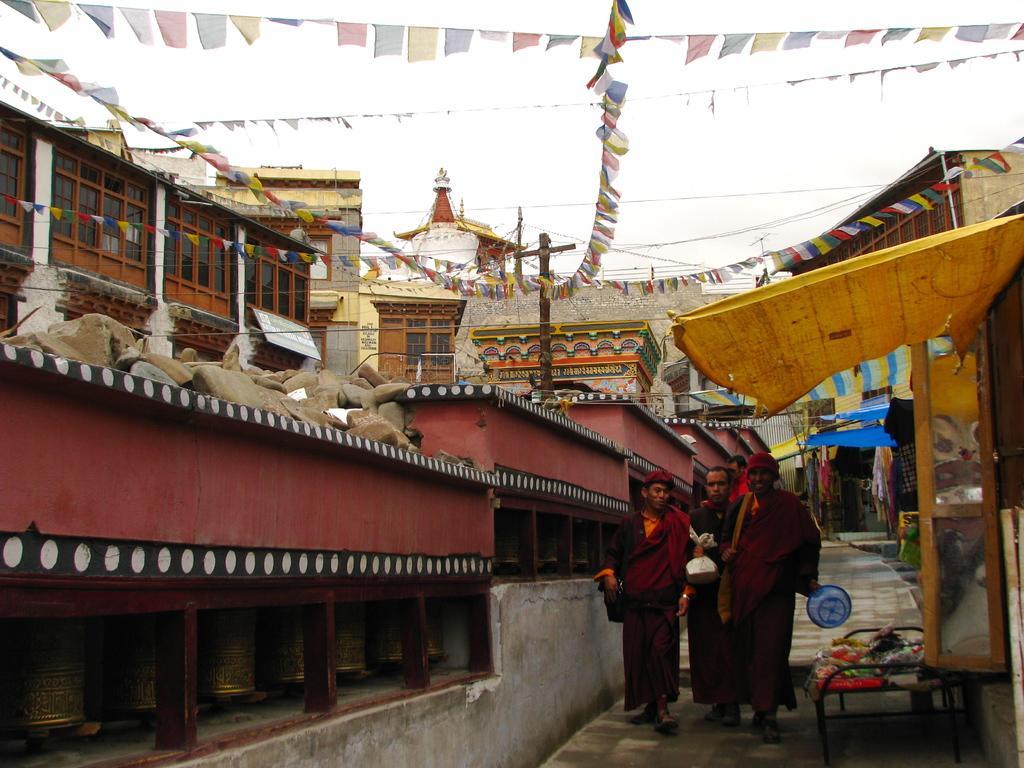Please provide a concise description of this image. In this picture I see the path in the center and I see few people who are on it and on the left side of this image I see number of buildings and on the right side of this image I see few stalls and on the top of this image I see the wires on which there are colorful papers and in the background I see the sky. 